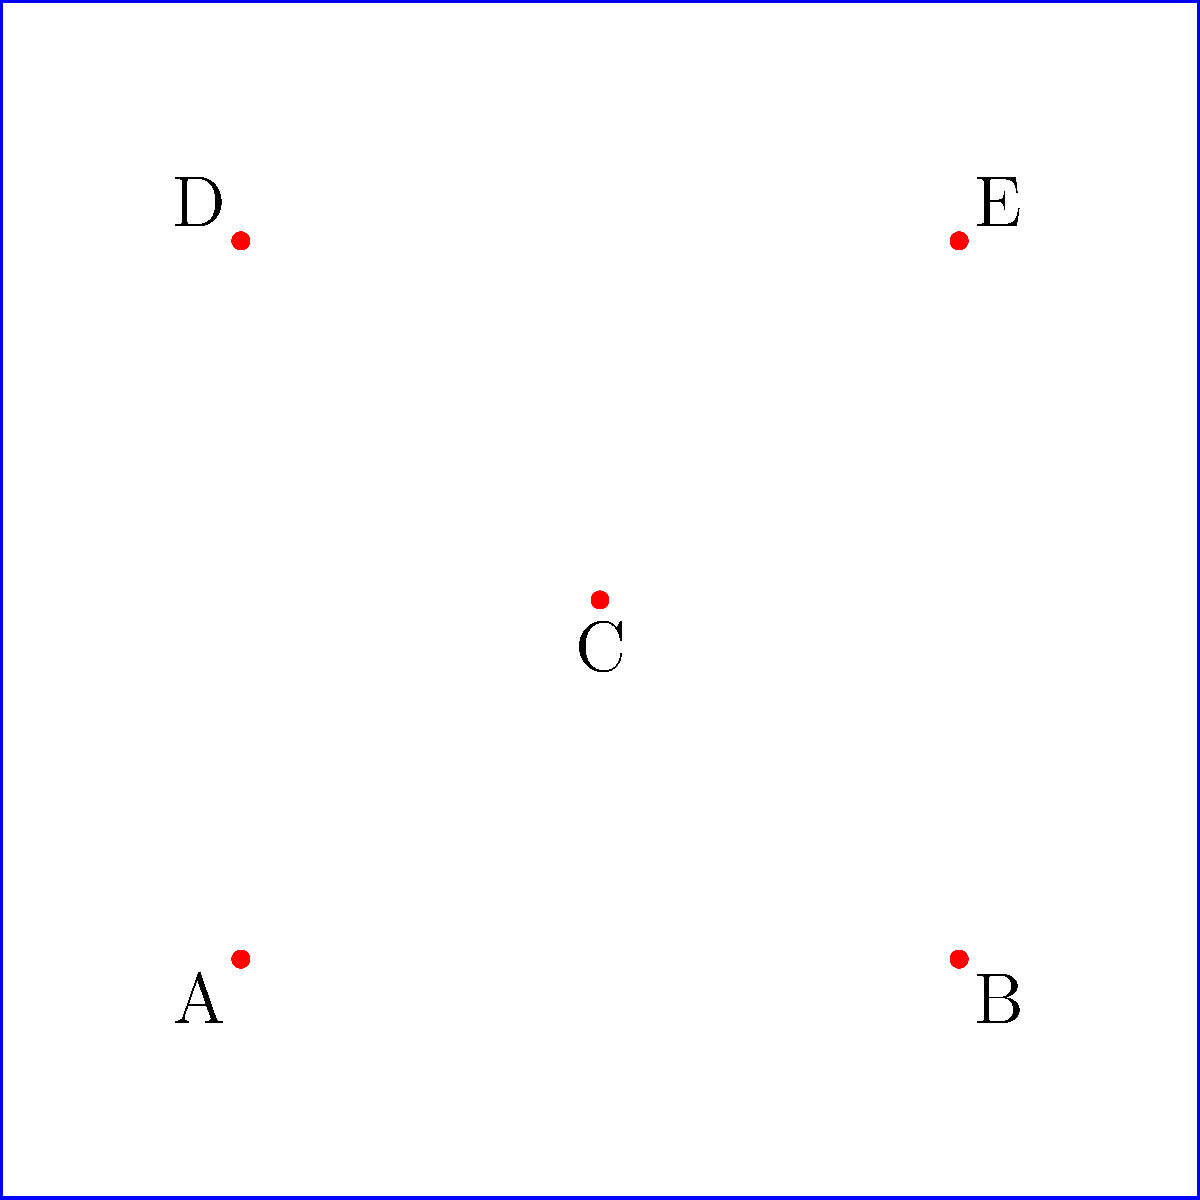Study the positions of the security personnel (red dots) in the compound for 30 seconds. Then, without referring back to the image, determine the total number of diagonal connections that can be made between the security personnel, where a diagonal connection is defined as a line that passes through the center of the compound (point C). To solve this problem, let's follow these steps:

1. Identify the center point: Point C (5,5) is at the center of the compound.

2. Identify possible diagonal connections:
   - A (2,2) to E (8,8): passes through C
   - B (8,2) to D (2,8): passes through C

3. Count the number of diagonal connections:
   - A to E: 1 connection
   - B to D: 1 connection

4. Calculate the total:
   $$ \text{Total diagonal connections} = 1 + 1 = 2 $$

Therefore, there are 2 diagonal connections that pass through the center of the compound.
Answer: 2 